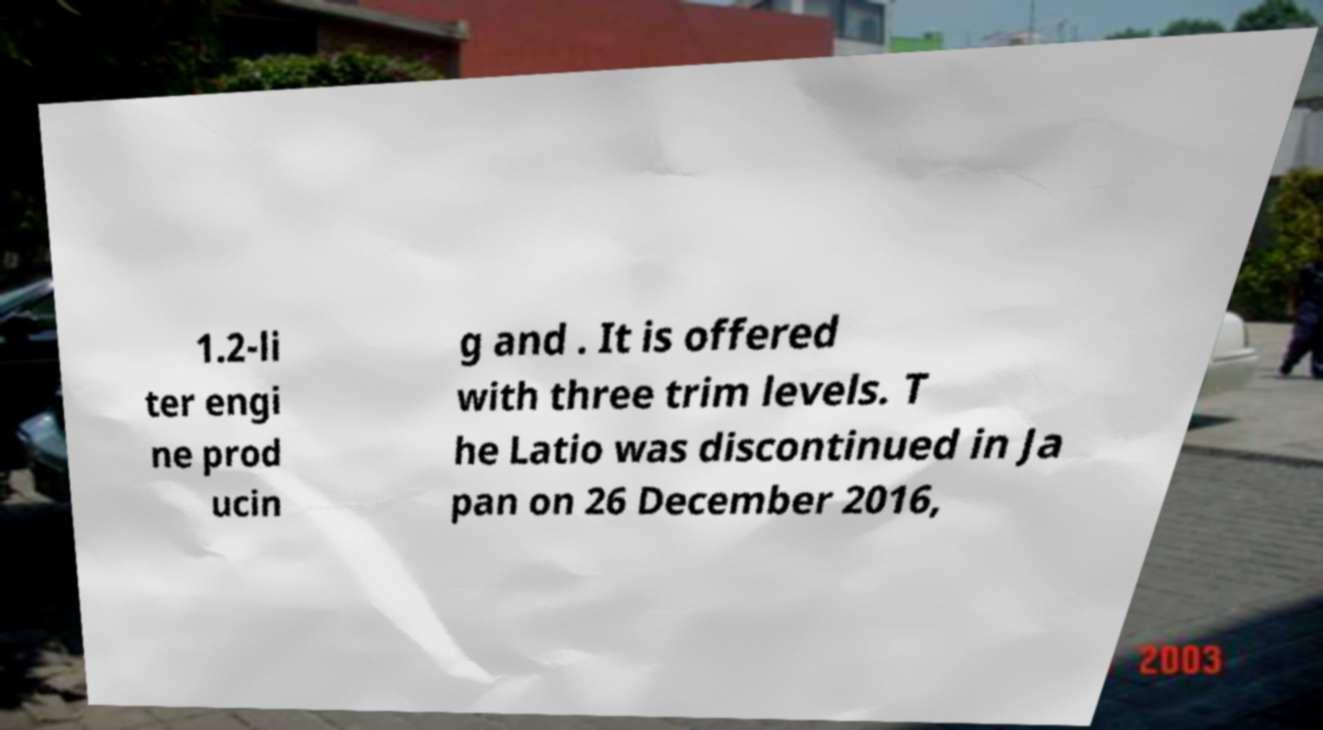There's text embedded in this image that I need extracted. Can you transcribe it verbatim? 1.2-li ter engi ne prod ucin g and . It is offered with three trim levels. T he Latio was discontinued in Ja pan on 26 December 2016, 